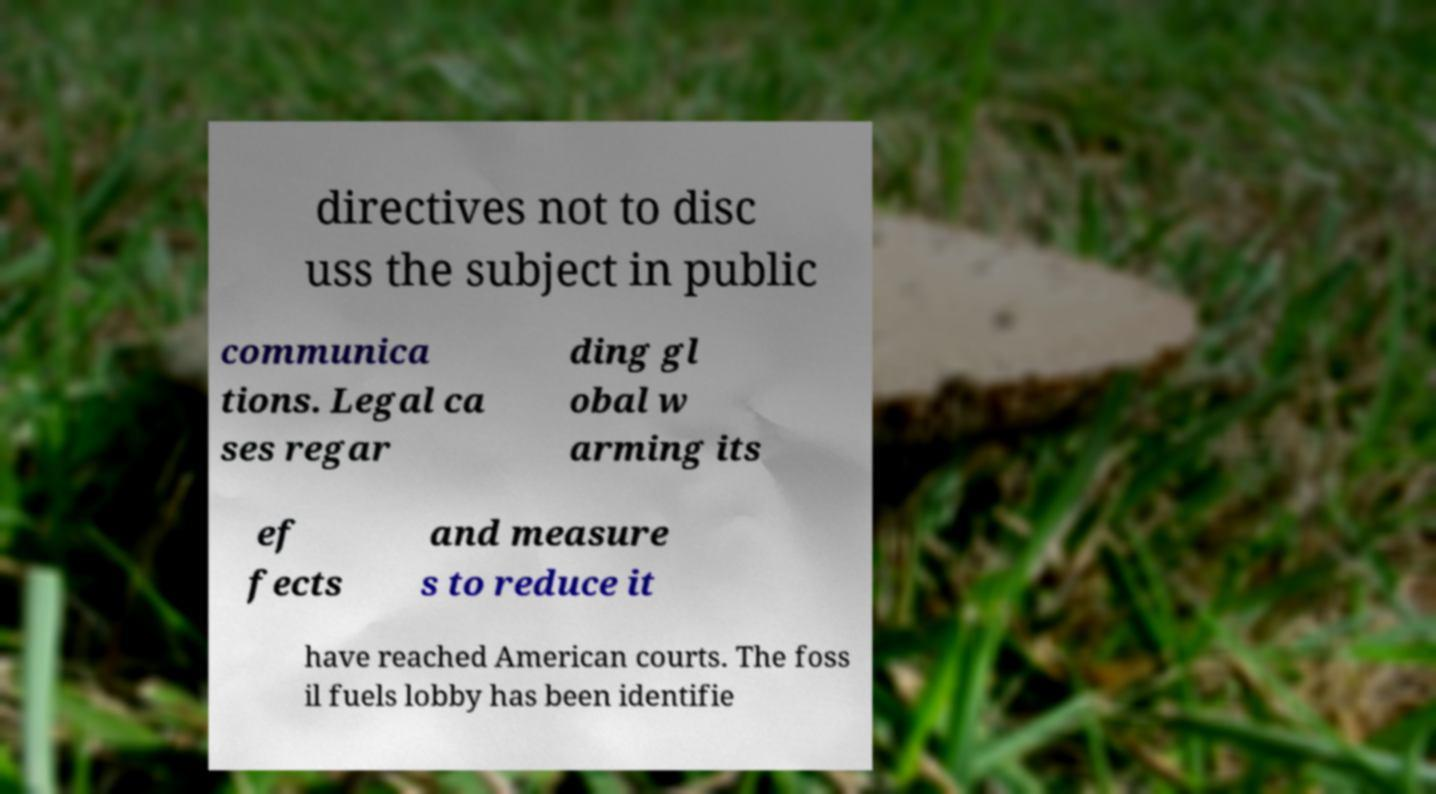I need the written content from this picture converted into text. Can you do that? directives not to disc uss the subject in public communica tions. Legal ca ses regar ding gl obal w arming its ef fects and measure s to reduce it have reached American courts. The foss il fuels lobby has been identifie 